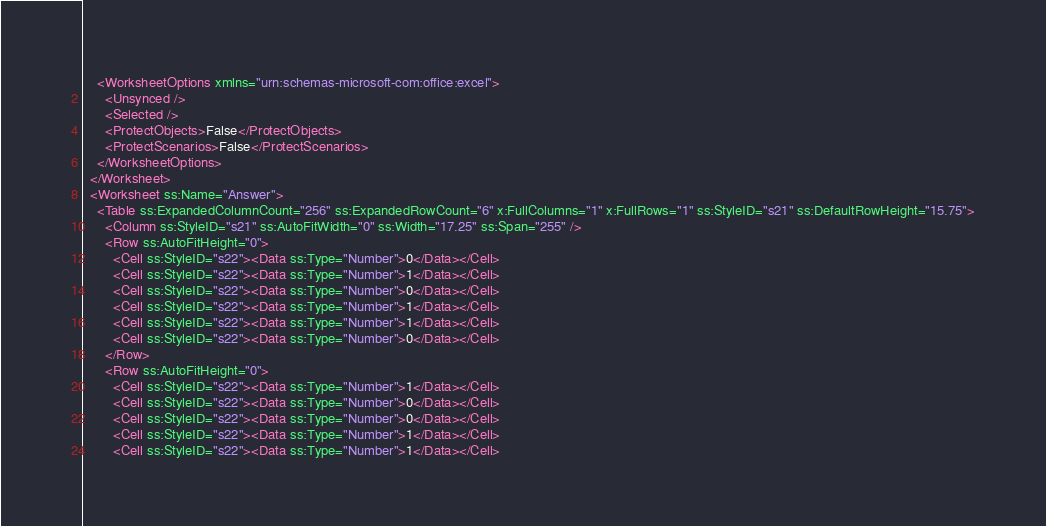Convert code to text. <code><loc_0><loc_0><loc_500><loc_500><_XML_>    <WorksheetOptions xmlns="urn:schemas-microsoft-com:office:excel">
      <Unsynced />
      <Selected />
      <ProtectObjects>False</ProtectObjects>
      <ProtectScenarios>False</ProtectScenarios>
    </WorksheetOptions>
  </Worksheet>
  <Worksheet ss:Name="Answer">
    <Table ss:ExpandedColumnCount="256" ss:ExpandedRowCount="6" x:FullColumns="1" x:FullRows="1" ss:StyleID="s21" ss:DefaultRowHeight="15.75">
      <Column ss:StyleID="s21" ss:AutoFitWidth="0" ss:Width="17.25" ss:Span="255" />
      <Row ss:AutoFitHeight="0">
        <Cell ss:StyleID="s22"><Data ss:Type="Number">0</Data></Cell>
        <Cell ss:StyleID="s22"><Data ss:Type="Number">1</Data></Cell>
        <Cell ss:StyleID="s22"><Data ss:Type="Number">0</Data></Cell>
        <Cell ss:StyleID="s22"><Data ss:Type="Number">1</Data></Cell>
        <Cell ss:StyleID="s22"><Data ss:Type="Number">1</Data></Cell>
        <Cell ss:StyleID="s22"><Data ss:Type="Number">0</Data></Cell>
      </Row>
      <Row ss:AutoFitHeight="0">
        <Cell ss:StyleID="s22"><Data ss:Type="Number">1</Data></Cell>
        <Cell ss:StyleID="s22"><Data ss:Type="Number">0</Data></Cell>
        <Cell ss:StyleID="s22"><Data ss:Type="Number">0</Data></Cell>
        <Cell ss:StyleID="s22"><Data ss:Type="Number">1</Data></Cell>
        <Cell ss:StyleID="s22"><Data ss:Type="Number">1</Data></Cell></code> 